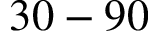<formula> <loc_0><loc_0><loc_500><loc_500>3 0 - 9 0</formula> 